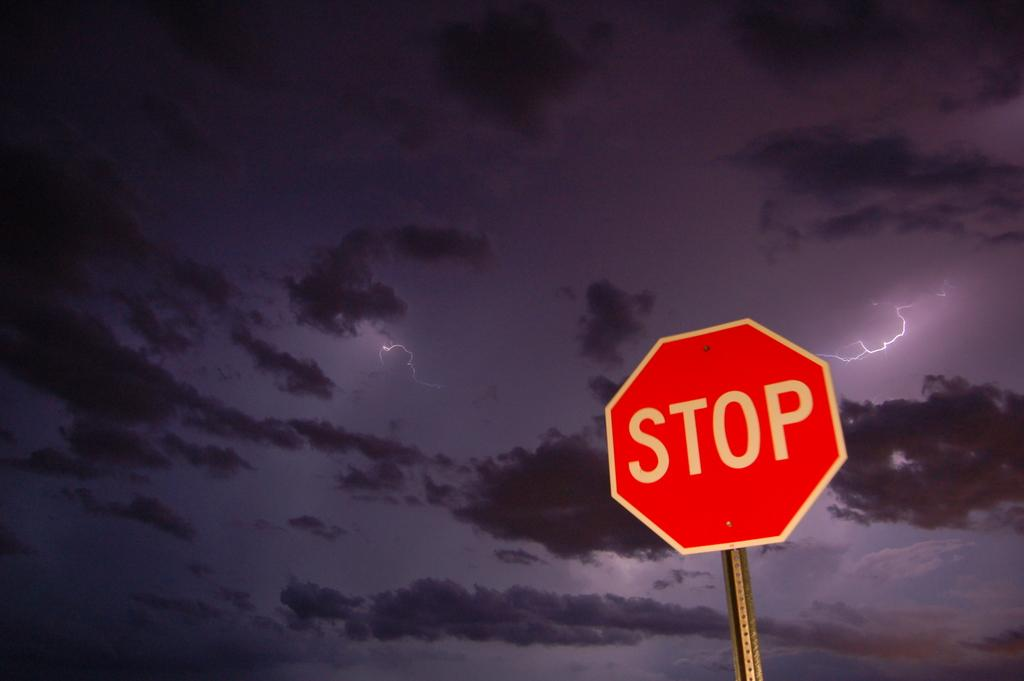<image>
Share a concise interpretation of the image provided. A stop sign is shown with a dark and stormy sky in the background. 